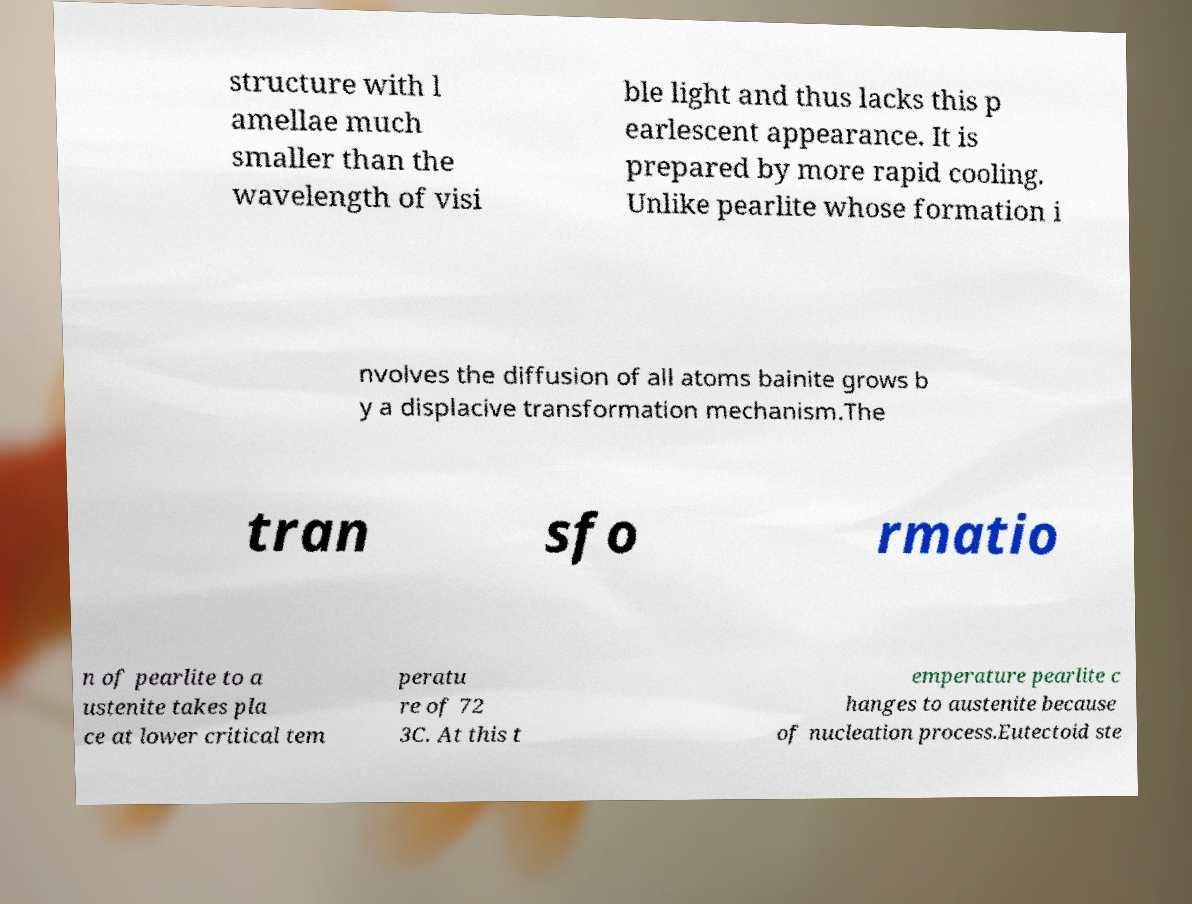Can you read and provide the text displayed in the image?This photo seems to have some interesting text. Can you extract and type it out for me? structure with l amellae much smaller than the wavelength of visi ble light and thus lacks this p earlescent appearance. It is prepared by more rapid cooling. Unlike pearlite whose formation i nvolves the diffusion of all atoms bainite grows b y a displacive transformation mechanism.The tran sfo rmatio n of pearlite to a ustenite takes pla ce at lower critical tem peratu re of 72 3C. At this t emperature pearlite c hanges to austenite because of nucleation process.Eutectoid ste 